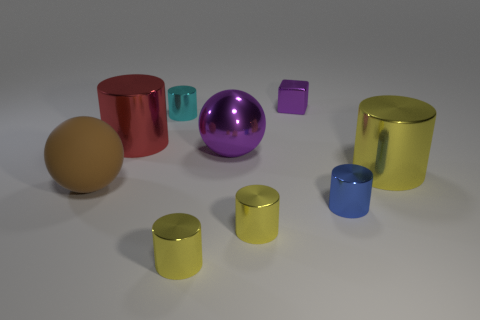What number of metal things are tiny purple objects or tiny cylinders?
Provide a succinct answer. 5. The big metallic thing right of the tiny metallic block has what shape?
Offer a very short reply. Cylinder. The blue cylinder that is made of the same material as the large purple thing is what size?
Give a very brief answer. Small. There is a large metallic object that is in front of the red metallic cylinder and to the left of the small purple metal object; what is its shape?
Give a very brief answer. Sphere. Do the big cylinder on the right side of the large metallic ball and the rubber thing have the same color?
Your answer should be very brief. No. Do the yellow metal object behind the brown thing and the big brown object that is to the left of the big purple thing have the same shape?
Provide a short and direct response. No. What is the size of the yellow metal object that is behind the brown rubber thing?
Your answer should be compact. Large. There is a sphere in front of the big metallic thing that is on the right side of the metal ball; what is its size?
Your answer should be compact. Large. Is the number of cylinders greater than the number of purple shiny blocks?
Provide a succinct answer. Yes. Is the number of purple things that are behind the small cyan cylinder greater than the number of rubber objects left of the blue cylinder?
Make the answer very short. No. 